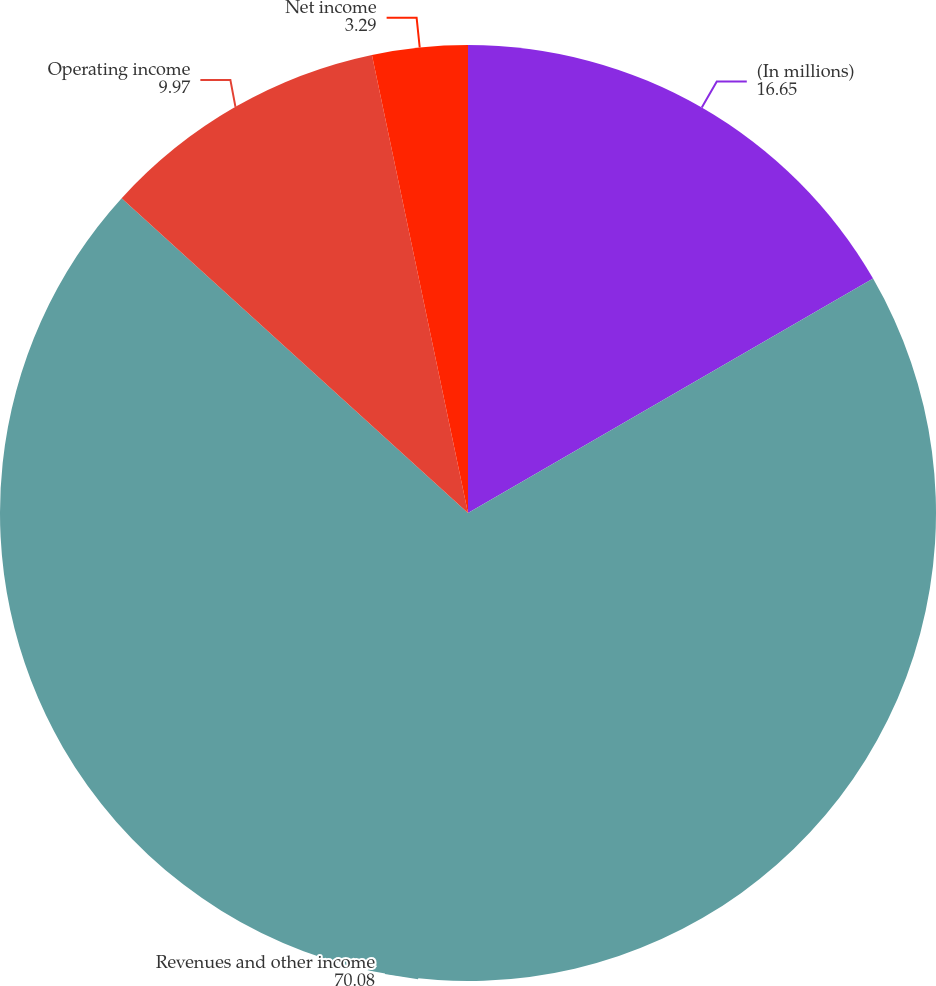Convert chart to OTSL. <chart><loc_0><loc_0><loc_500><loc_500><pie_chart><fcel>(In millions)<fcel>Revenues and other income<fcel>Operating income<fcel>Net income<nl><fcel>16.65%<fcel>70.08%<fcel>9.97%<fcel>3.29%<nl></chart> 